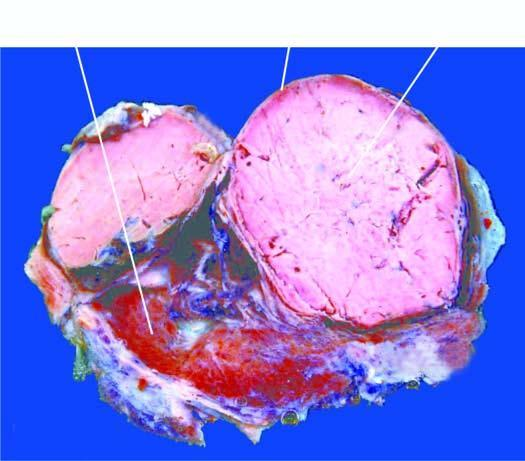what does sectioned surface of the thyroid show?
Answer the question using a single word or phrase. A solitary nodule having capsule 